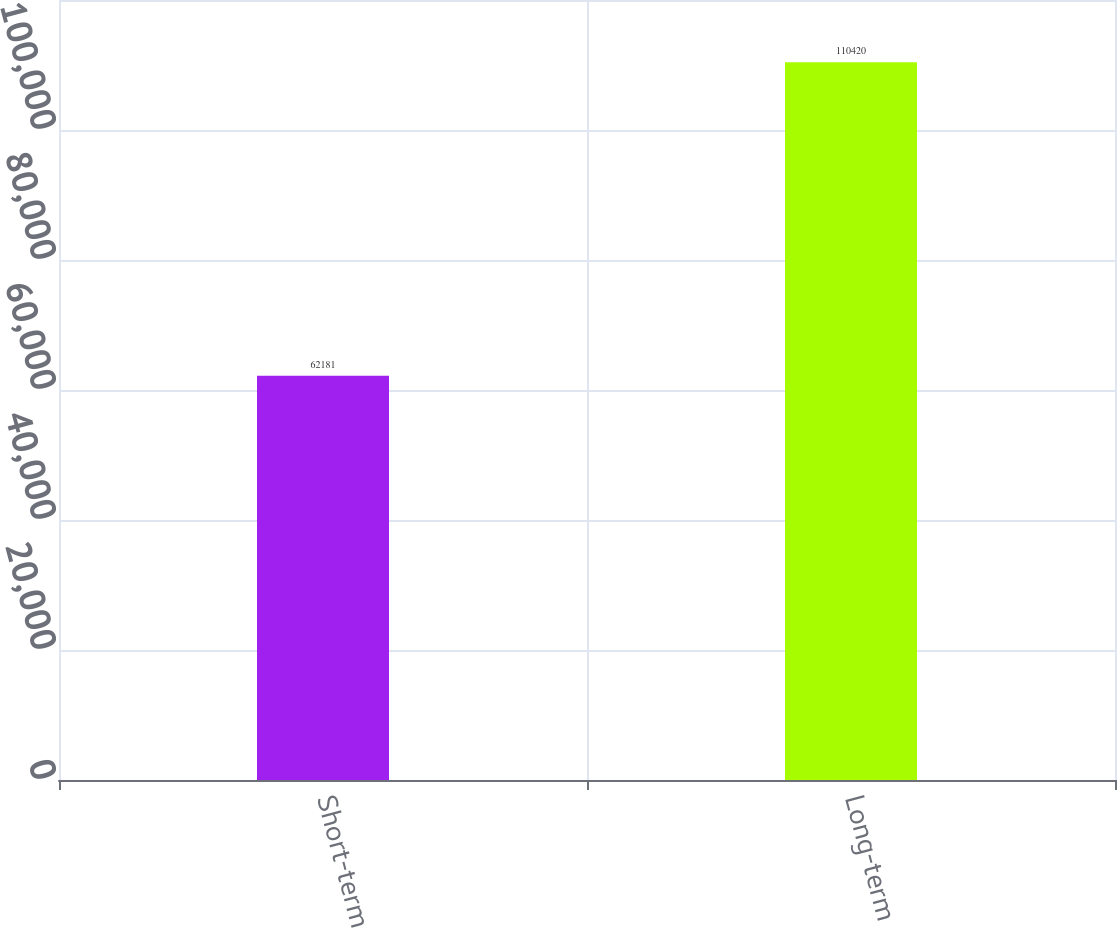Convert chart to OTSL. <chart><loc_0><loc_0><loc_500><loc_500><bar_chart><fcel>Short-term<fcel>Long-term<nl><fcel>62181<fcel>110420<nl></chart> 